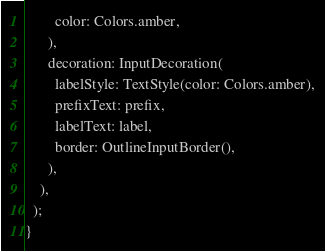<code> <loc_0><loc_0><loc_500><loc_500><_Dart_>        color: Colors.amber,
      ),
      decoration: InputDecoration(
        labelStyle: TextStyle(color: Colors.amber),
        prefixText: prefix,
        labelText: label,
        border: OutlineInputBorder(),
      ),
    ),
  );
}
</code> 